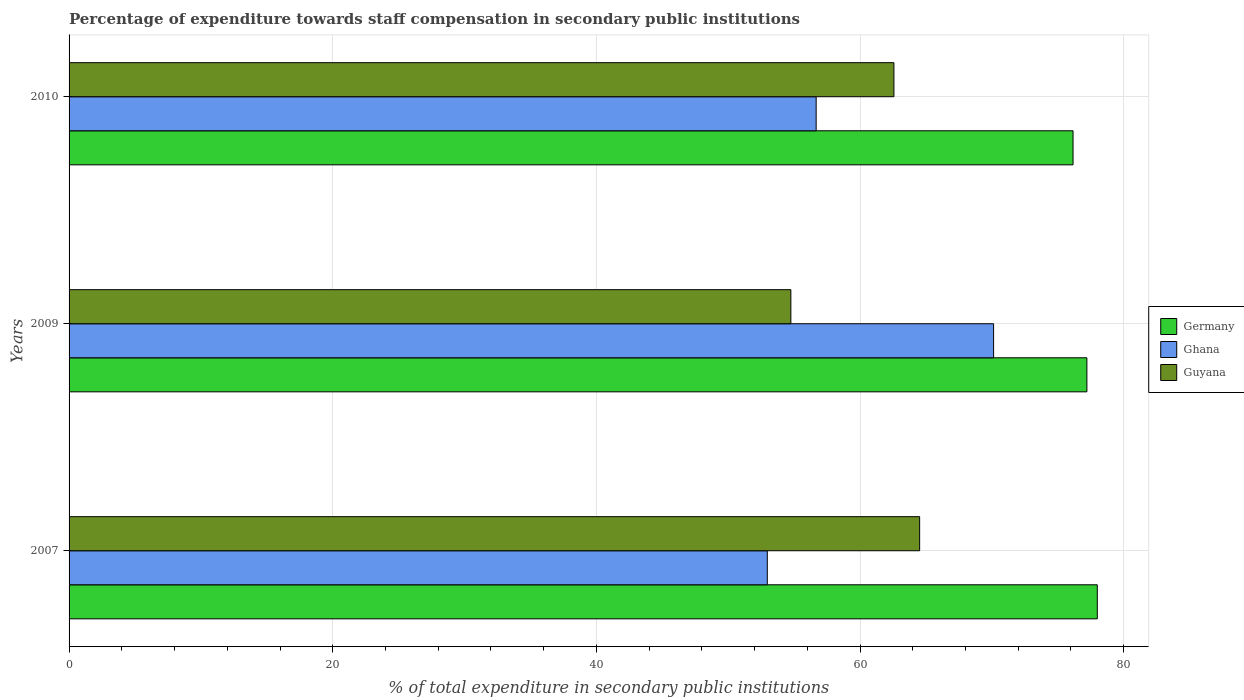How many groups of bars are there?
Provide a short and direct response. 3. Are the number of bars per tick equal to the number of legend labels?
Offer a very short reply. Yes. How many bars are there on the 3rd tick from the top?
Ensure brevity in your answer.  3. How many bars are there on the 2nd tick from the bottom?
Give a very brief answer. 3. In how many cases, is the number of bars for a given year not equal to the number of legend labels?
Offer a terse response. 0. What is the percentage of expenditure towards staff compensation in Guyana in 2010?
Provide a short and direct response. 62.57. Across all years, what is the maximum percentage of expenditure towards staff compensation in Ghana?
Keep it short and to the point. 70.13. Across all years, what is the minimum percentage of expenditure towards staff compensation in Germany?
Your answer should be compact. 76.16. In which year was the percentage of expenditure towards staff compensation in Ghana maximum?
Ensure brevity in your answer.  2009. What is the total percentage of expenditure towards staff compensation in Germany in the graph?
Give a very brief answer. 231.37. What is the difference between the percentage of expenditure towards staff compensation in Ghana in 2007 and that in 2009?
Provide a succinct answer. -17.17. What is the difference between the percentage of expenditure towards staff compensation in Guyana in 2010 and the percentage of expenditure towards staff compensation in Ghana in 2009?
Offer a very short reply. -7.56. What is the average percentage of expenditure towards staff compensation in Germany per year?
Your answer should be very brief. 77.12. In the year 2010, what is the difference between the percentage of expenditure towards staff compensation in Ghana and percentage of expenditure towards staff compensation in Germany?
Offer a terse response. -19.49. What is the ratio of the percentage of expenditure towards staff compensation in Ghana in 2007 to that in 2009?
Provide a succinct answer. 0.76. Is the percentage of expenditure towards staff compensation in Ghana in 2009 less than that in 2010?
Provide a succinct answer. No. What is the difference between the highest and the second highest percentage of expenditure towards staff compensation in Germany?
Give a very brief answer. 0.79. What is the difference between the highest and the lowest percentage of expenditure towards staff compensation in Ghana?
Your response must be concise. 17.17. Is the sum of the percentage of expenditure towards staff compensation in Germany in 2007 and 2009 greater than the maximum percentage of expenditure towards staff compensation in Guyana across all years?
Ensure brevity in your answer.  Yes. What does the 2nd bar from the top in 2009 represents?
Offer a very short reply. Ghana. What does the 3rd bar from the bottom in 2010 represents?
Your answer should be very brief. Guyana. Is it the case that in every year, the sum of the percentage of expenditure towards staff compensation in Germany and percentage of expenditure towards staff compensation in Guyana is greater than the percentage of expenditure towards staff compensation in Ghana?
Make the answer very short. Yes. Are all the bars in the graph horizontal?
Provide a short and direct response. Yes. What is the difference between two consecutive major ticks on the X-axis?
Offer a terse response. 20. Does the graph contain any zero values?
Offer a terse response. No. Does the graph contain grids?
Give a very brief answer. Yes. Where does the legend appear in the graph?
Offer a very short reply. Center right. How are the legend labels stacked?
Offer a terse response. Vertical. What is the title of the graph?
Give a very brief answer. Percentage of expenditure towards staff compensation in secondary public institutions. Does "Montenegro" appear as one of the legend labels in the graph?
Offer a terse response. No. What is the label or title of the X-axis?
Your answer should be compact. % of total expenditure in secondary public institutions. What is the label or title of the Y-axis?
Make the answer very short. Years. What is the % of total expenditure in secondary public institutions in Germany in 2007?
Ensure brevity in your answer.  78. What is the % of total expenditure in secondary public institutions of Ghana in 2007?
Your answer should be very brief. 52.97. What is the % of total expenditure in secondary public institutions of Guyana in 2007?
Keep it short and to the point. 64.52. What is the % of total expenditure in secondary public institutions in Germany in 2009?
Make the answer very short. 77.21. What is the % of total expenditure in secondary public institutions in Ghana in 2009?
Provide a short and direct response. 70.13. What is the % of total expenditure in secondary public institutions in Guyana in 2009?
Make the answer very short. 54.75. What is the % of total expenditure in secondary public institutions in Germany in 2010?
Ensure brevity in your answer.  76.16. What is the % of total expenditure in secondary public institutions of Ghana in 2010?
Give a very brief answer. 56.67. What is the % of total expenditure in secondary public institutions of Guyana in 2010?
Your answer should be very brief. 62.57. Across all years, what is the maximum % of total expenditure in secondary public institutions of Germany?
Your response must be concise. 78. Across all years, what is the maximum % of total expenditure in secondary public institutions in Ghana?
Provide a succinct answer. 70.13. Across all years, what is the maximum % of total expenditure in secondary public institutions in Guyana?
Your answer should be compact. 64.52. Across all years, what is the minimum % of total expenditure in secondary public institutions of Germany?
Your answer should be very brief. 76.16. Across all years, what is the minimum % of total expenditure in secondary public institutions of Ghana?
Your answer should be very brief. 52.97. Across all years, what is the minimum % of total expenditure in secondary public institutions in Guyana?
Your response must be concise. 54.75. What is the total % of total expenditure in secondary public institutions in Germany in the graph?
Offer a very short reply. 231.37. What is the total % of total expenditure in secondary public institutions of Ghana in the graph?
Offer a very short reply. 179.77. What is the total % of total expenditure in secondary public institutions in Guyana in the graph?
Your answer should be very brief. 181.85. What is the difference between the % of total expenditure in secondary public institutions of Germany in 2007 and that in 2009?
Keep it short and to the point. 0.79. What is the difference between the % of total expenditure in secondary public institutions in Ghana in 2007 and that in 2009?
Ensure brevity in your answer.  -17.17. What is the difference between the % of total expenditure in secondary public institutions in Guyana in 2007 and that in 2009?
Keep it short and to the point. 9.77. What is the difference between the % of total expenditure in secondary public institutions of Germany in 2007 and that in 2010?
Offer a very short reply. 1.84. What is the difference between the % of total expenditure in secondary public institutions in Ghana in 2007 and that in 2010?
Your answer should be very brief. -3.71. What is the difference between the % of total expenditure in secondary public institutions in Guyana in 2007 and that in 2010?
Your answer should be compact. 1.95. What is the difference between the % of total expenditure in secondary public institutions of Germany in 2009 and that in 2010?
Offer a very short reply. 1.05. What is the difference between the % of total expenditure in secondary public institutions in Ghana in 2009 and that in 2010?
Your response must be concise. 13.46. What is the difference between the % of total expenditure in secondary public institutions in Guyana in 2009 and that in 2010?
Your answer should be very brief. -7.82. What is the difference between the % of total expenditure in secondary public institutions of Germany in 2007 and the % of total expenditure in secondary public institutions of Ghana in 2009?
Make the answer very short. 7.87. What is the difference between the % of total expenditure in secondary public institutions in Germany in 2007 and the % of total expenditure in secondary public institutions in Guyana in 2009?
Your answer should be very brief. 23.25. What is the difference between the % of total expenditure in secondary public institutions in Ghana in 2007 and the % of total expenditure in secondary public institutions in Guyana in 2009?
Offer a very short reply. -1.79. What is the difference between the % of total expenditure in secondary public institutions of Germany in 2007 and the % of total expenditure in secondary public institutions of Ghana in 2010?
Make the answer very short. 21.33. What is the difference between the % of total expenditure in secondary public institutions of Germany in 2007 and the % of total expenditure in secondary public institutions of Guyana in 2010?
Give a very brief answer. 15.43. What is the difference between the % of total expenditure in secondary public institutions of Ghana in 2007 and the % of total expenditure in secondary public institutions of Guyana in 2010?
Offer a terse response. -9.61. What is the difference between the % of total expenditure in secondary public institutions of Germany in 2009 and the % of total expenditure in secondary public institutions of Ghana in 2010?
Offer a very short reply. 20.54. What is the difference between the % of total expenditure in secondary public institutions in Germany in 2009 and the % of total expenditure in secondary public institutions in Guyana in 2010?
Give a very brief answer. 14.64. What is the difference between the % of total expenditure in secondary public institutions of Ghana in 2009 and the % of total expenditure in secondary public institutions of Guyana in 2010?
Keep it short and to the point. 7.56. What is the average % of total expenditure in secondary public institutions of Germany per year?
Your response must be concise. 77.12. What is the average % of total expenditure in secondary public institutions of Ghana per year?
Provide a succinct answer. 59.92. What is the average % of total expenditure in secondary public institutions of Guyana per year?
Offer a very short reply. 60.62. In the year 2007, what is the difference between the % of total expenditure in secondary public institutions in Germany and % of total expenditure in secondary public institutions in Ghana?
Your answer should be compact. 25.03. In the year 2007, what is the difference between the % of total expenditure in secondary public institutions of Germany and % of total expenditure in secondary public institutions of Guyana?
Offer a very short reply. 13.48. In the year 2007, what is the difference between the % of total expenditure in secondary public institutions in Ghana and % of total expenditure in secondary public institutions in Guyana?
Offer a very short reply. -11.56. In the year 2009, what is the difference between the % of total expenditure in secondary public institutions in Germany and % of total expenditure in secondary public institutions in Ghana?
Offer a very short reply. 7.08. In the year 2009, what is the difference between the % of total expenditure in secondary public institutions of Germany and % of total expenditure in secondary public institutions of Guyana?
Keep it short and to the point. 22.46. In the year 2009, what is the difference between the % of total expenditure in secondary public institutions of Ghana and % of total expenditure in secondary public institutions of Guyana?
Ensure brevity in your answer.  15.38. In the year 2010, what is the difference between the % of total expenditure in secondary public institutions in Germany and % of total expenditure in secondary public institutions in Ghana?
Give a very brief answer. 19.49. In the year 2010, what is the difference between the % of total expenditure in secondary public institutions in Germany and % of total expenditure in secondary public institutions in Guyana?
Keep it short and to the point. 13.59. In the year 2010, what is the difference between the % of total expenditure in secondary public institutions of Ghana and % of total expenditure in secondary public institutions of Guyana?
Your response must be concise. -5.9. What is the ratio of the % of total expenditure in secondary public institutions in Germany in 2007 to that in 2009?
Offer a very short reply. 1.01. What is the ratio of the % of total expenditure in secondary public institutions in Ghana in 2007 to that in 2009?
Make the answer very short. 0.76. What is the ratio of the % of total expenditure in secondary public institutions of Guyana in 2007 to that in 2009?
Offer a very short reply. 1.18. What is the ratio of the % of total expenditure in secondary public institutions of Germany in 2007 to that in 2010?
Provide a succinct answer. 1.02. What is the ratio of the % of total expenditure in secondary public institutions in Ghana in 2007 to that in 2010?
Provide a short and direct response. 0.93. What is the ratio of the % of total expenditure in secondary public institutions in Guyana in 2007 to that in 2010?
Your response must be concise. 1.03. What is the ratio of the % of total expenditure in secondary public institutions of Germany in 2009 to that in 2010?
Make the answer very short. 1.01. What is the ratio of the % of total expenditure in secondary public institutions of Ghana in 2009 to that in 2010?
Make the answer very short. 1.24. What is the ratio of the % of total expenditure in secondary public institutions of Guyana in 2009 to that in 2010?
Provide a short and direct response. 0.88. What is the difference between the highest and the second highest % of total expenditure in secondary public institutions of Germany?
Give a very brief answer. 0.79. What is the difference between the highest and the second highest % of total expenditure in secondary public institutions in Ghana?
Offer a very short reply. 13.46. What is the difference between the highest and the second highest % of total expenditure in secondary public institutions in Guyana?
Your response must be concise. 1.95. What is the difference between the highest and the lowest % of total expenditure in secondary public institutions of Germany?
Provide a short and direct response. 1.84. What is the difference between the highest and the lowest % of total expenditure in secondary public institutions in Ghana?
Give a very brief answer. 17.17. What is the difference between the highest and the lowest % of total expenditure in secondary public institutions in Guyana?
Keep it short and to the point. 9.77. 